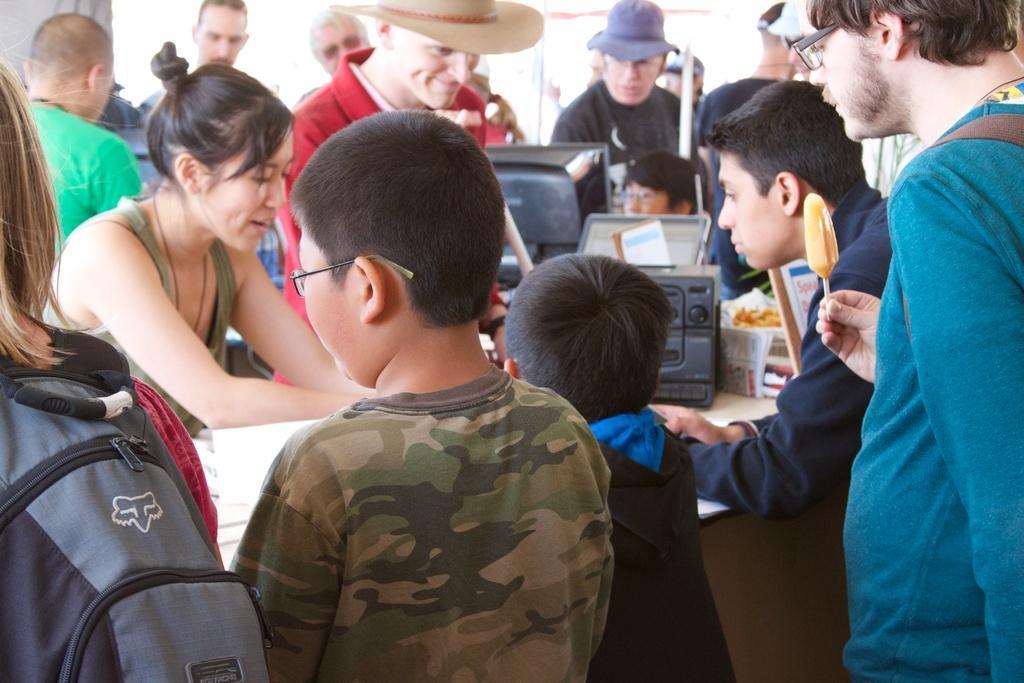Can you describe this image briefly? In this picture we can see some group of people standing around the table on which there are some things. 